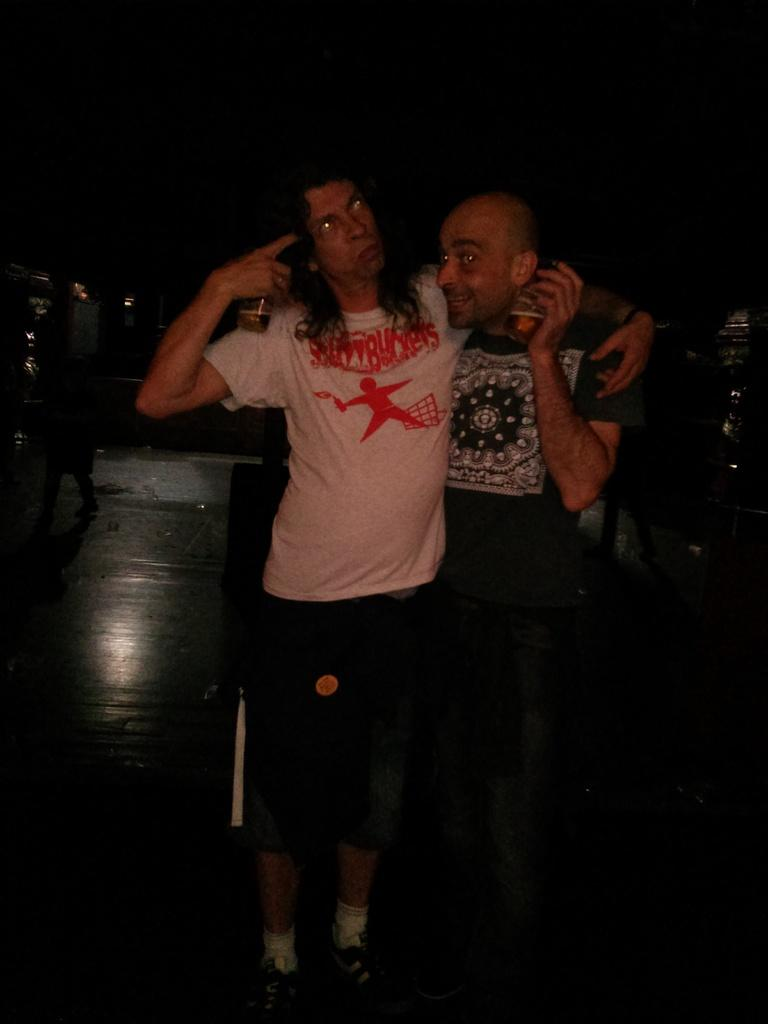Who is present in the image? There are men in the image. What is the position of the men in relation to the floor? The men are standing on the floor. Where are the men located within the image? The men are located in the center of the image. What type of pencil is being used by the men to perform magic in the image? There is no pencil or magic present in the image; it only shows men standing on the floor. 